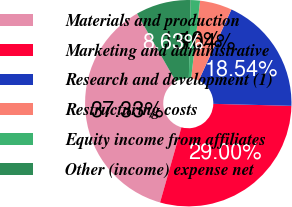<chart> <loc_0><loc_0><loc_500><loc_500><pie_chart><fcel>Materials and production<fcel>Marketing and administrative<fcel>Research and development (1)<fcel>Restructuring costs<fcel>Equity income from affiliates<fcel>Other (income) expense net<nl><fcel>37.33%<fcel>29.0%<fcel>18.54%<fcel>5.04%<fcel>1.46%<fcel>8.63%<nl></chart> 